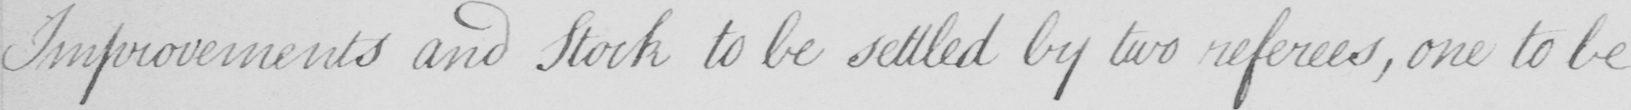Please transcribe the handwritten text in this image. Improvements and Stock to be settled by two referees , one to be 